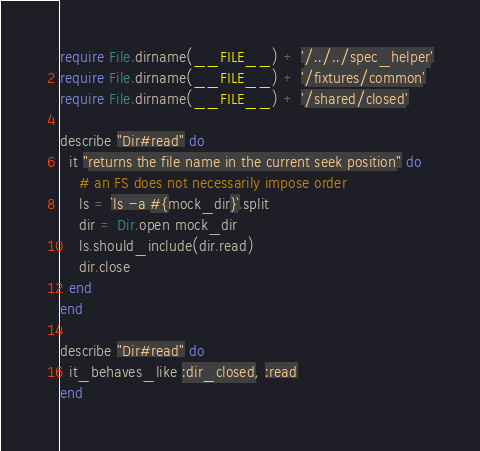Convert code to text. <code><loc_0><loc_0><loc_500><loc_500><_Ruby_>require File.dirname(__FILE__) + '/../../spec_helper'
require File.dirname(__FILE__) + '/fixtures/common'
require File.dirname(__FILE__) + '/shared/closed'

describe "Dir#read" do
  it "returns the file name in the current seek position" do
    # an FS does not necessarily impose order
    ls = `ls -a #{mock_dir}`.split
    dir = Dir.open mock_dir
    ls.should_include(dir.read)
    dir.close
  end
end

describe "Dir#read" do
  it_behaves_like :dir_closed, :read
end
</code> 